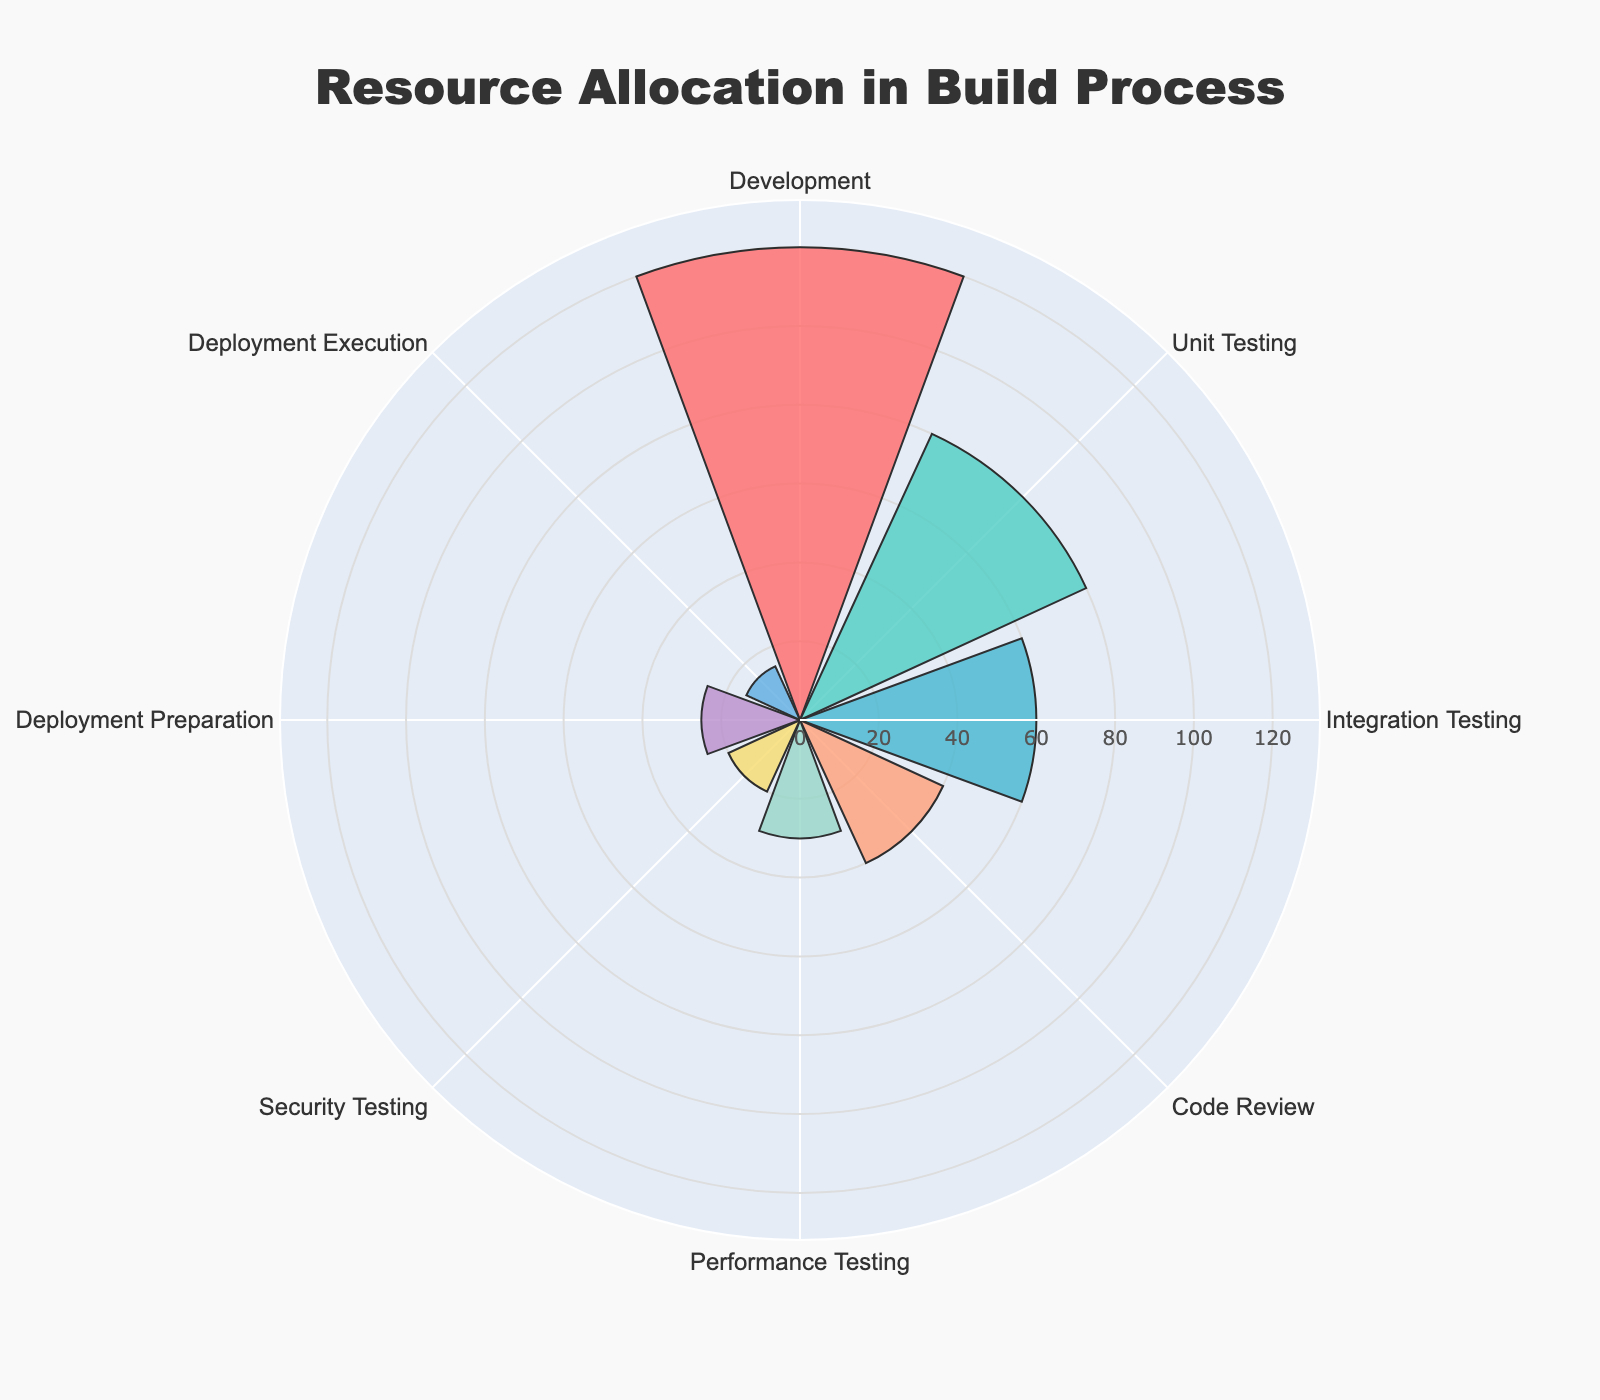What's the total amount of resources allocated to testing stages? Sum the hours allocated to Unit Testing, Integration Testing, Performance Testing, and Security Testing (80 + 60 + 30 + 20).
Answer: 190 hours Which stage has the highest resource allocation? Look for the stage with the longest bar. The 'Development' stage has the highest value at 120 hours.
Answer: Development How much more resources are allocated to Code Review compared to Deployment Execution? Subtract the hours for Deployment Execution from Code Review (40 - 15) to find the difference.
Answer: 25 hours Which stage has the least amount of allocated resources? Identify the stage with the shortest bar. The 'Deployment Execution' stage has the least value at 15 hours.
Answer: Deployment Execution How do the resources allocated to Unit Testing and Integration Testing compare? Compare the lengths of the bars for Unit Testing and Integration Testing. Unit Testing has 80 hours, and Integration Testing has 60 hours.
Answer: Unit Testing has more What is the average resource allocation per stage? Sum all the resource allocations and then divide by the number of stages (120 + 80 + 60 + 40 + 30 + 20 + 25 + 15) / 8. Average = 390 / 8.
Answer: 48.75 hours Is Code Review has more or less resource allocation than Deployment Preparation? Compare the values for Code Review (40 hours) and Deployment Preparation (25 hours). Code Review has more allocation.
Answer: Code Review has more What's the difference in resource allocation between the highest and the lowest stages? Subtract the value of the lowest stage (Deployment Execution, 15 hours) from the highest stage (Development, 120 hours).
Answer: 105 hours What portion of resources is dedicated to Deployment stages? Sum the hours for Deployment Preparation and Deployment Execution (25 + 15).
Answer: 40 hours Based on the chart, what stage follows Development in terms of the amount of resources allocated? Find the stage with the next longest bar after Development. Unit Testing follows Development with 80 hours.
Answer: Unit Testing 